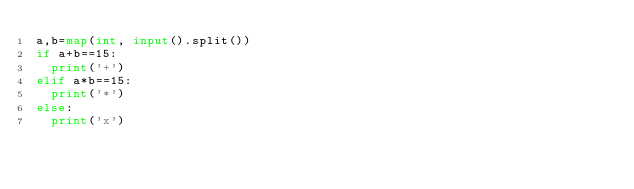Convert code to text. <code><loc_0><loc_0><loc_500><loc_500><_Python_>a,b=map(int, input().split())
if a+b==15:
  print('+')
elif a*b==15:
  print('*')
else:
  print('x')</code> 